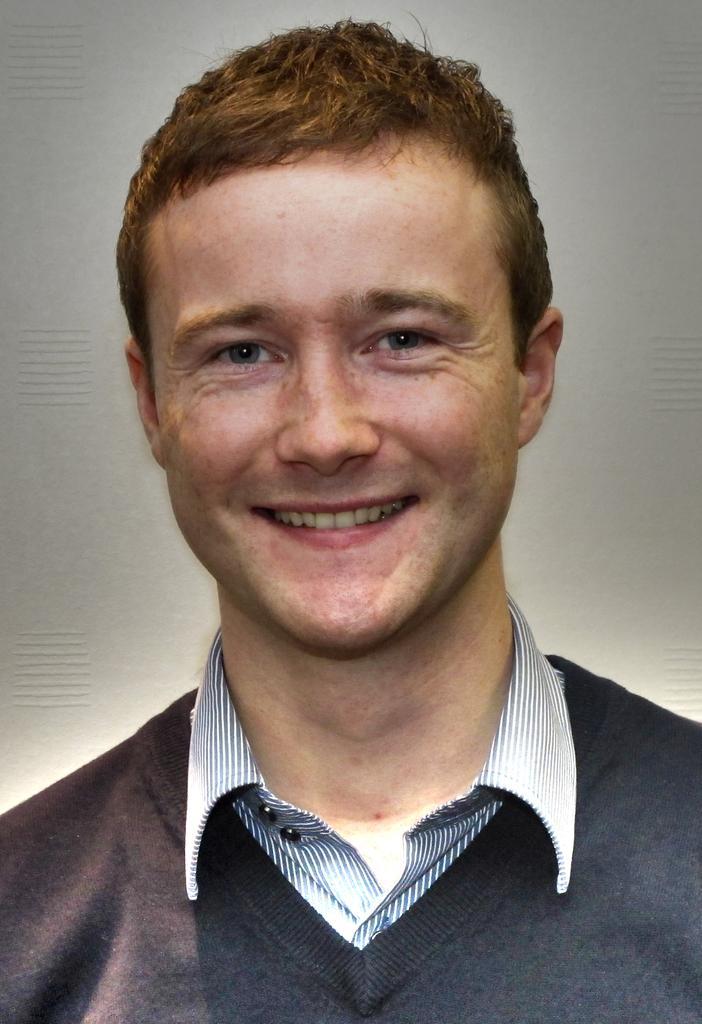In one or two sentences, can you explain what this image depicts? In this picture I can see a man with a smile on his face and I can see white color background. 